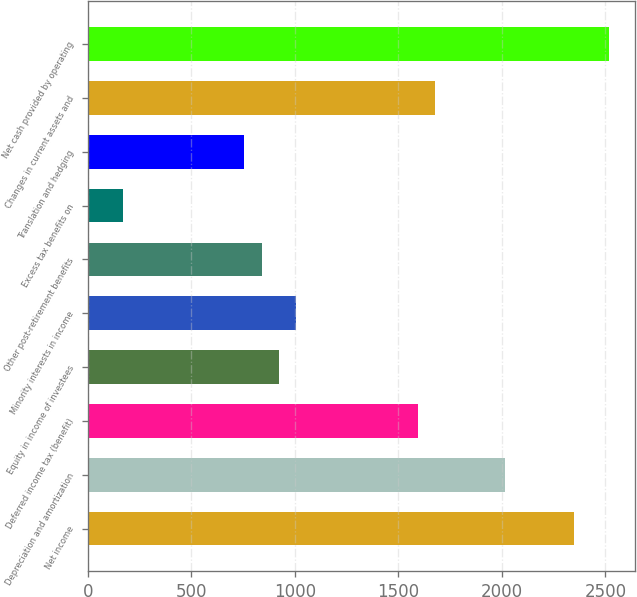<chart> <loc_0><loc_0><loc_500><loc_500><bar_chart><fcel>Net income<fcel>Depreciation and amortization<fcel>Deferred income tax (benefit)<fcel>Equity in income of investees<fcel>Minority interests in income<fcel>Other post-retirement benefits<fcel>Excess tax benefits on<fcel>Translation and hedging<fcel>Changes in current assets and<fcel>Net cash provided by operating<nl><fcel>2348.4<fcel>2013.2<fcel>1594.2<fcel>923.8<fcel>1007.6<fcel>840<fcel>169.6<fcel>756.2<fcel>1678<fcel>2516<nl></chart> 